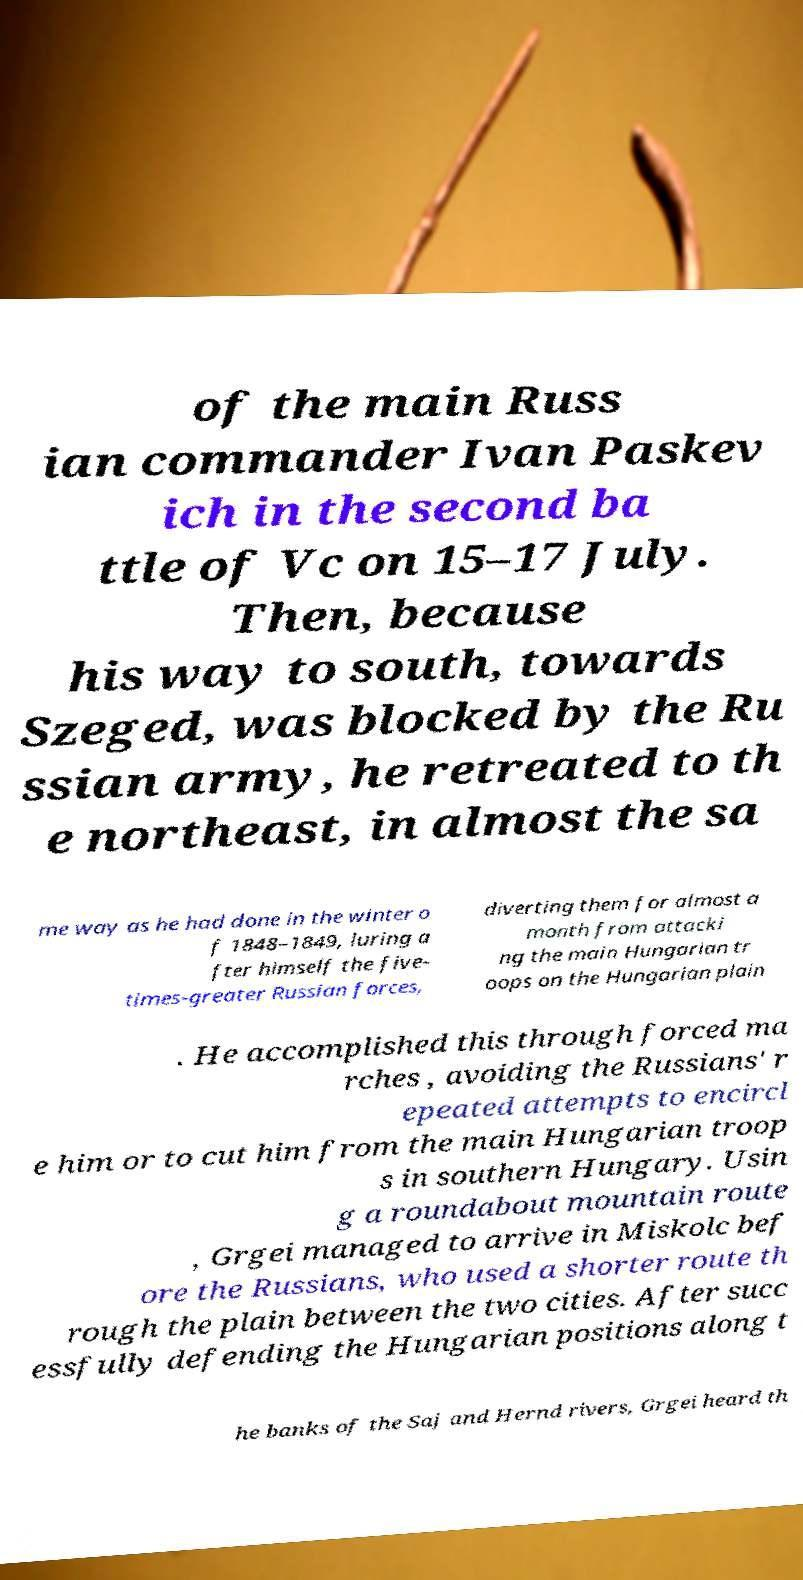For documentation purposes, I need the text within this image transcribed. Could you provide that? of the main Russ ian commander Ivan Paskev ich in the second ba ttle of Vc on 15–17 July. Then, because his way to south, towards Szeged, was blocked by the Ru ssian army, he retreated to th e northeast, in almost the sa me way as he had done in the winter o f 1848–1849, luring a fter himself the five- times-greater Russian forces, diverting them for almost a month from attacki ng the main Hungarian tr oops on the Hungarian plain . He accomplished this through forced ma rches , avoiding the Russians' r epeated attempts to encircl e him or to cut him from the main Hungarian troop s in southern Hungary. Usin g a roundabout mountain route , Grgei managed to arrive in Miskolc bef ore the Russians, who used a shorter route th rough the plain between the two cities. After succ essfully defending the Hungarian positions along t he banks of the Saj and Hernd rivers, Grgei heard th 